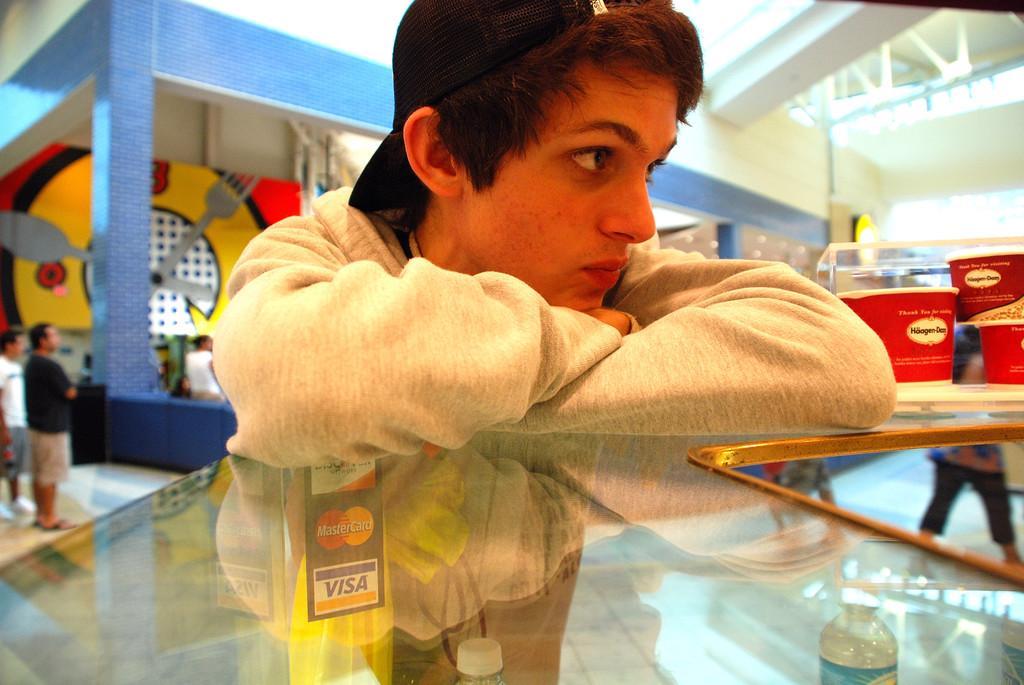Could you give a brief overview of what you see in this image? In this image, we can see a person in front of the table. This person is wearing clothes and cap. There are two persons on the left side of the image standing and wearing clothes. In the background, we can see a building. 